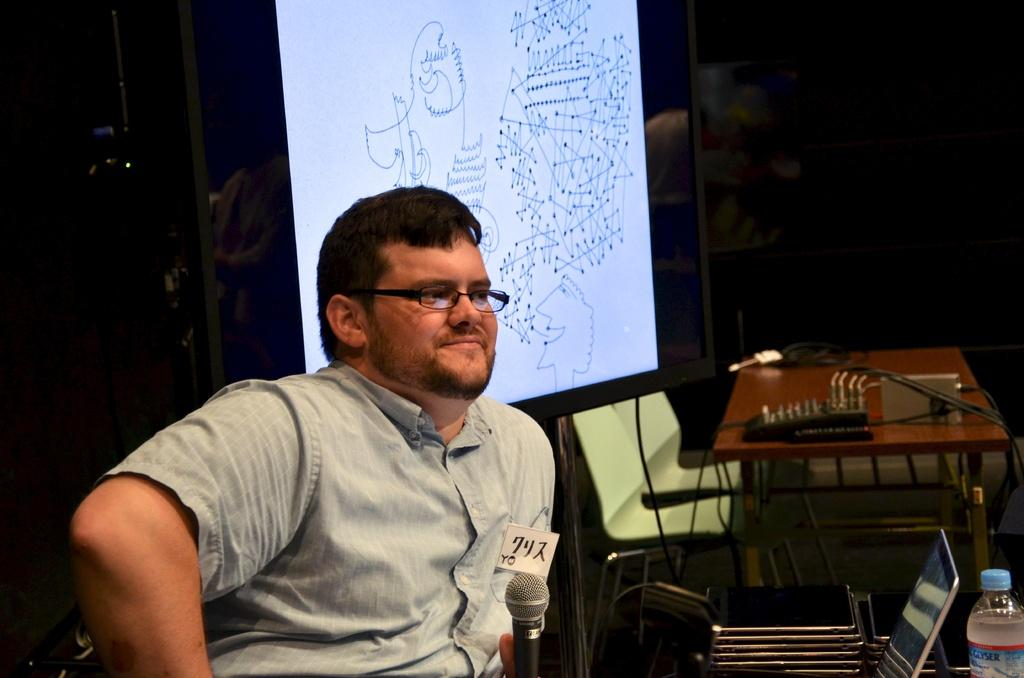What is the man in the image doing? The man is sitting in the image and holding a microphone. What can be seen in the background of the image? There is a table, bags, a chair, and a board in the background. What might the man be using the microphone for? The man might be using the microphone for speaking or singing. How many ladybugs can be seen on the man's shoulder in the image? There are no ladybugs visible on the man's shoulder in the image. What type of love is being expressed in the image? The image does not depict any expressions of love; it features a man holding a microphone. 